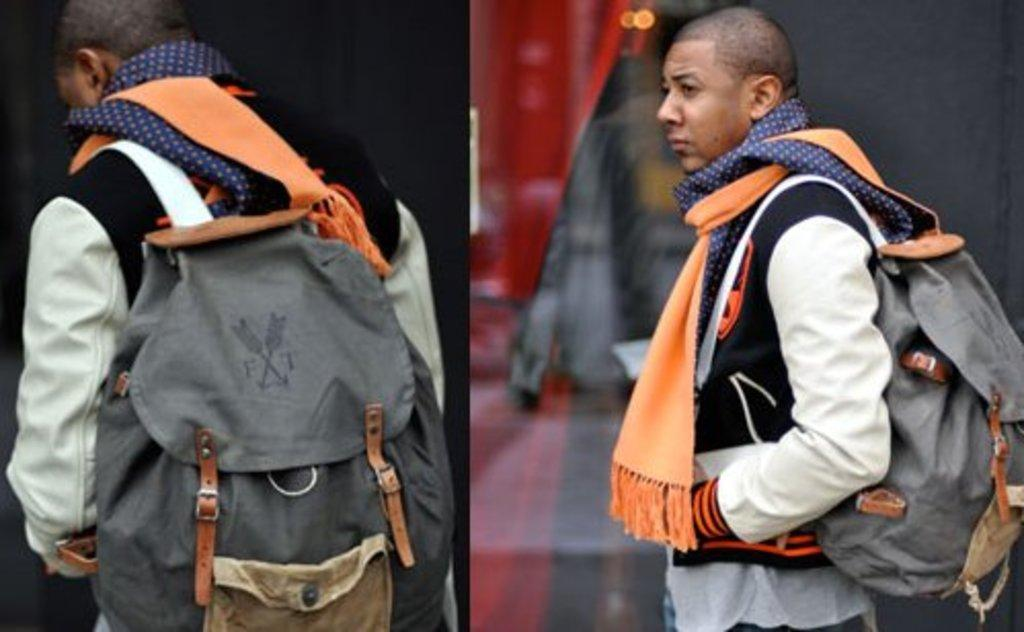<image>
Write a terse but informative summary of the picture. A man has an F T backpack slung over his shoulder. 